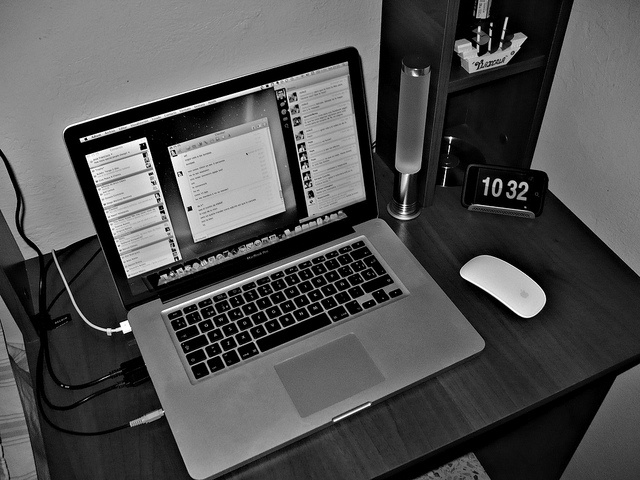Describe the objects in this image and their specific colors. I can see laptop in gray, black, darkgray, and lightgray tones, keyboard in gray, black, darkgray, and lightgray tones, clock in gray, black, darkgray, and lightgray tones, and mouse in gray, lightgray, darkgray, and black tones in this image. 